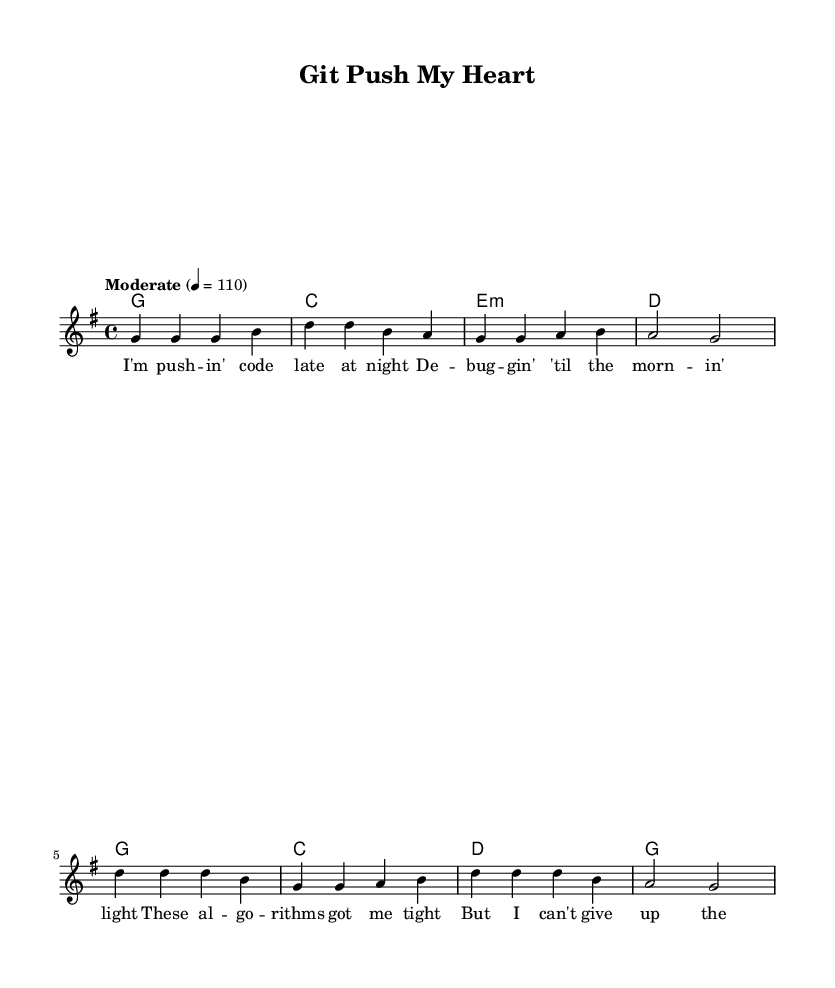What is the key signature of this music? The key signature is G major, which has one sharp (F#). It can be identified by looking at the key signature symbol located at the beginning of the staff—there is a single sharp on the F line.
Answer: G major What is the time signature of this music? The time signature is 4/4, which indicates four beats per measure with the quarter note receiving one beat. This can be found at the beginning of the score, right after the key signature.
Answer: 4/4 What is the tempo marking of this music? The tempo marking is "Moderate" with a metronome marking of 110. This indicates how fast the music should be played and is written above the staff near the beginning of the piece.
Answer: Moderate 4 = 110 How many measures are there in the verse? There are four measures in the verse part of the song, as you can count each line of notation on the staff before the chorus begins.
Answer: 4 What chords are used in the chorus? The chords used in the chorus are D, G, and A. Each chord corresponds to the measure in the chord names section following the structure of the lyrics and should be identified by referencing the chord symbols above the staff during the chorus section.
Answer: D, G, A What is the title of the song? The title of the song is "Git Push My Heart," which can be found prominently displayed at the top of the sheet music in the header section.
Answer: Git Push My Heart What concept is commonly associated with the chorus lyrics? The concept is "git," which refers to version control in software development and is evocated in the chorus lyrics through phrases like "Git push my heart to you," highlighting the blend of coding terminology with romantic sentiment.
Answer: Git 